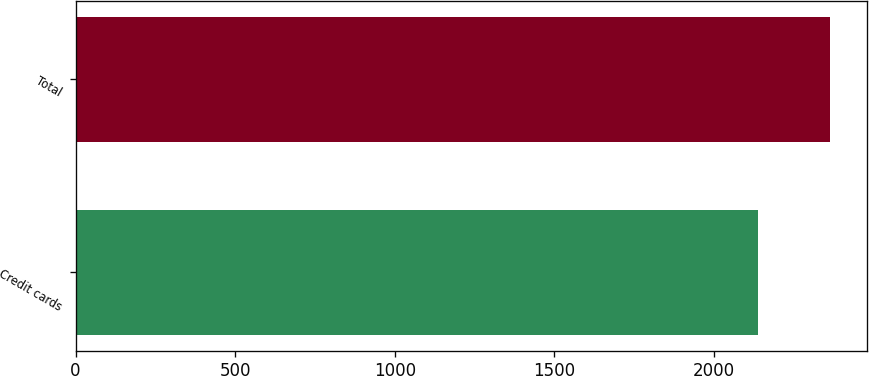Convert chart. <chart><loc_0><loc_0><loc_500><loc_500><bar_chart><fcel>Credit cards<fcel>Total<nl><fcel>2137<fcel>2362<nl></chart> 